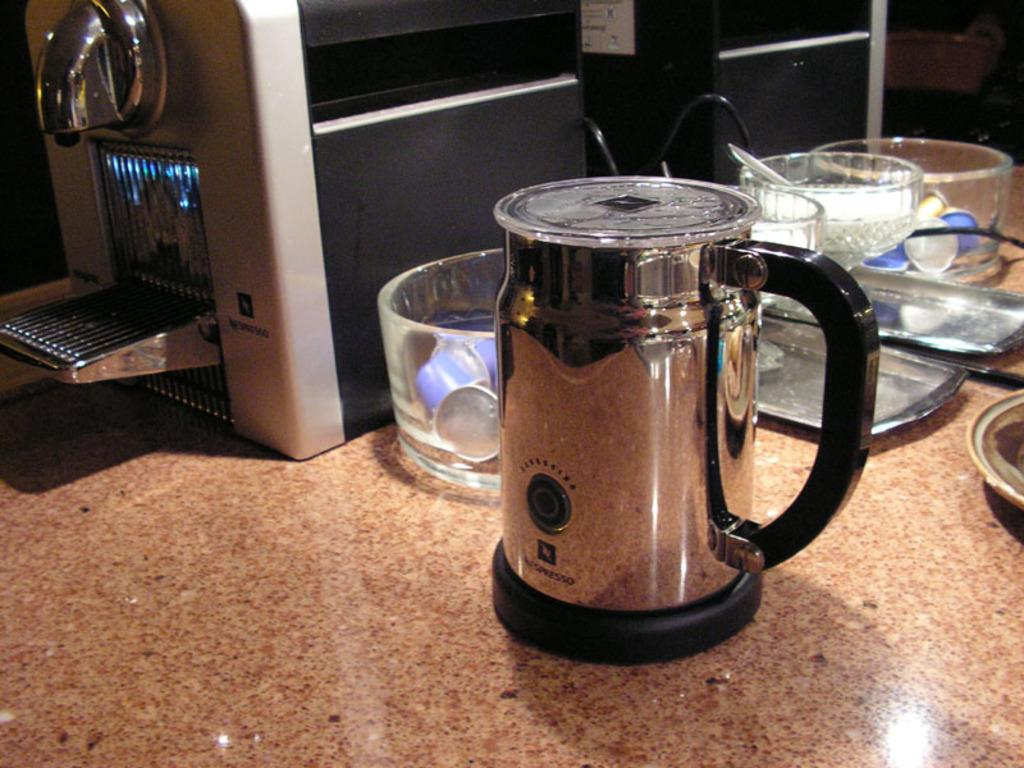What type of surface is at the bottom of the image? There is a marble surface at the bottom of the image. What appliance is placed on the marble surface? A coffee machine is placed on the marble. What type of container is present on the marble surface? A jar is present on the marble. What type of dishware is visible on the marble surface? Bowls are visible on the marble. What type of flatware is placed on the marble surface? Trays are placed on the marble. Can you see any clouds in the image? There are no clouds visible in the image, as it features a marble surface with various objects placed on it. 